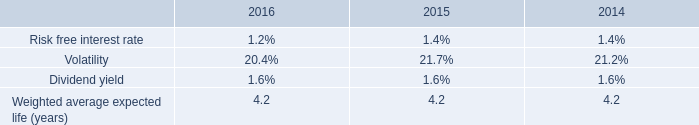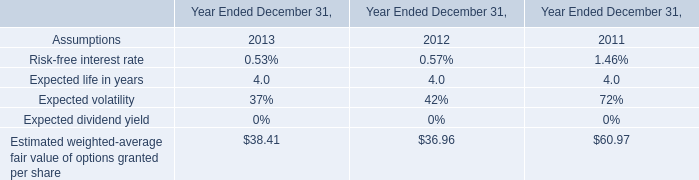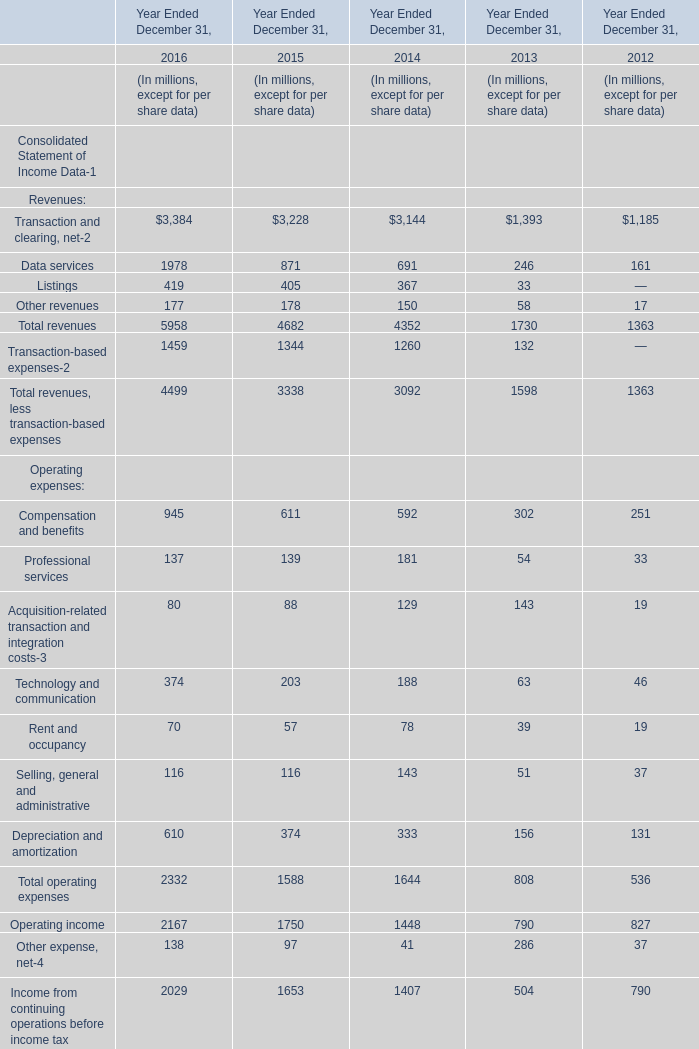In the year with largest amount of Data services, what's the increasing rate of Total operating expenses? 
Computations: ((2332 - 1588) / 2332)
Answer: 0.31904. 